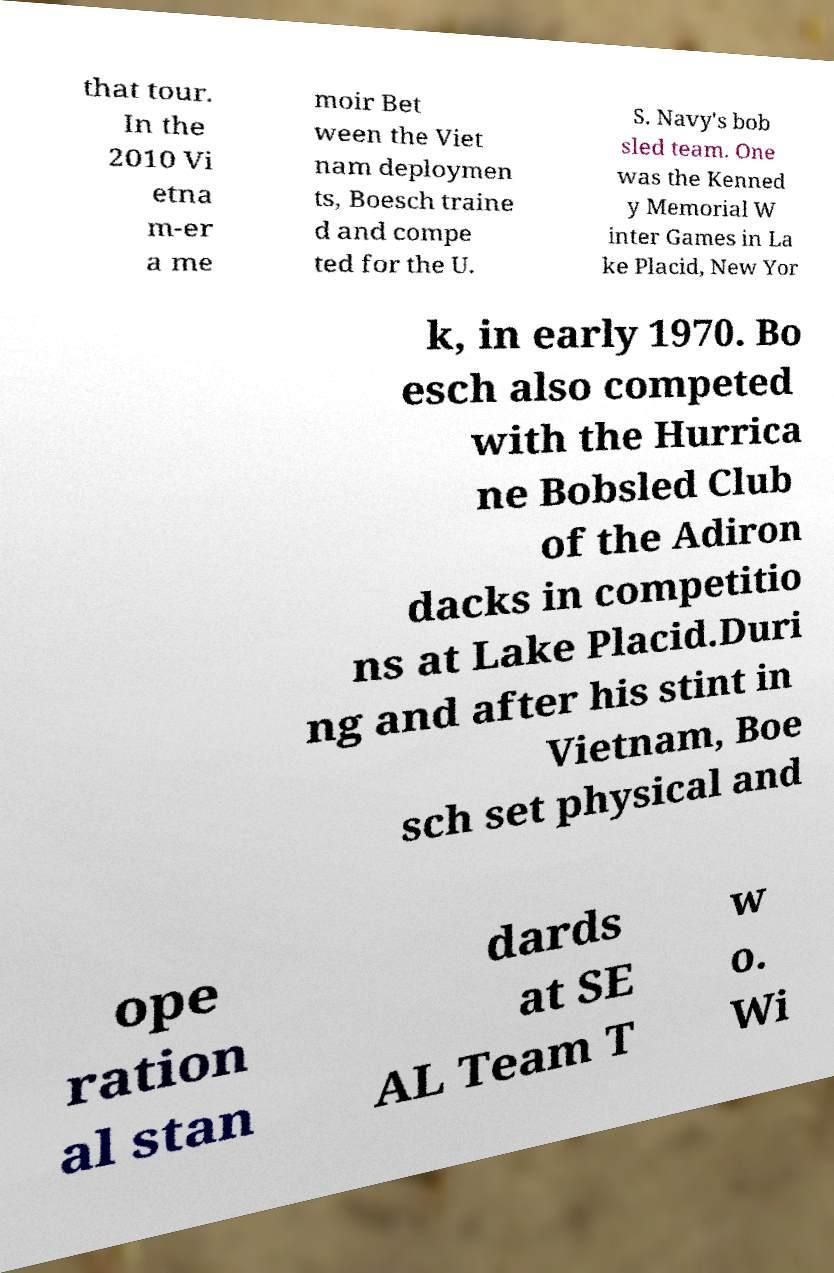Could you assist in decoding the text presented in this image and type it out clearly? that tour. In the 2010 Vi etna m-er a me moir Bet ween the Viet nam deploymen ts, Boesch traine d and compe ted for the U. S. Navy's bob sled team. One was the Kenned y Memorial W inter Games in La ke Placid, New Yor k, in early 1970. Bo esch also competed with the Hurrica ne Bobsled Club of the Adiron dacks in competitio ns at Lake Placid.Duri ng and after his stint in Vietnam, Boe sch set physical and ope ration al stan dards at SE AL Team T w o. Wi 